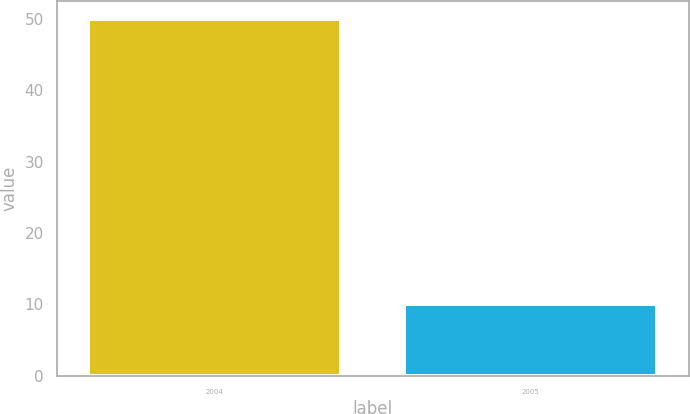Convert chart to OTSL. <chart><loc_0><loc_0><loc_500><loc_500><bar_chart><fcel>2004<fcel>2005<nl><fcel>50<fcel>10<nl></chart> 